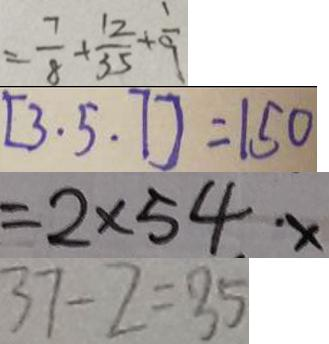<formula> <loc_0><loc_0><loc_500><loc_500>= \frac { 7 } { 8 } + \frac { 1 2 } { 3 5 } + \frac { 1 } { 9 } 
 [ 3 . 5 . 7 ] = 1 5 0 
 = 2 \times 5 4 \cdot x 
 3 7 - 2 = 3 5</formula> 